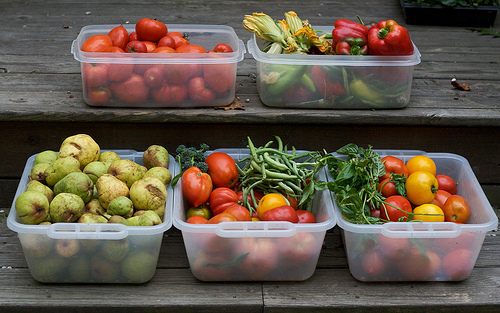<image>
Is the guava in front of the tomatoes? No. The guava is not in front of the tomatoes. The spatial positioning shows a different relationship between these objects. 